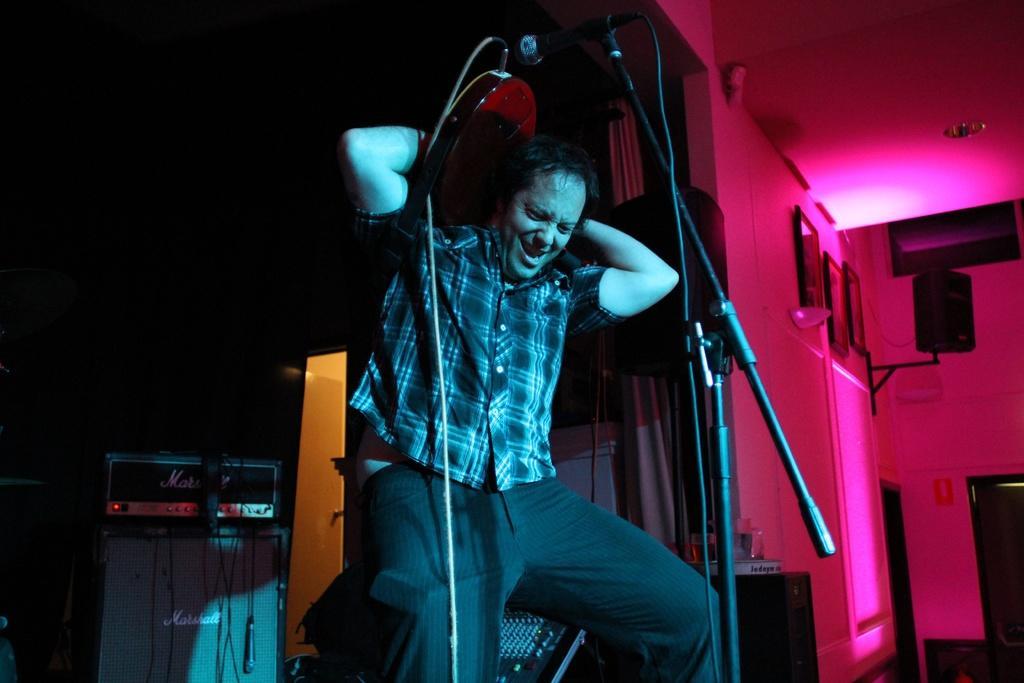Please provide a concise description of this image. In this there is a person holding a musical instrument and standing, there is a stand, there is a wire, there is a microphone, there is a wall towards the right of the image, there is a speaker, there are photo frames, there is a roof, there are objectś towards the left of the image, there is glass on the surface, there is a dark background behind the person. 